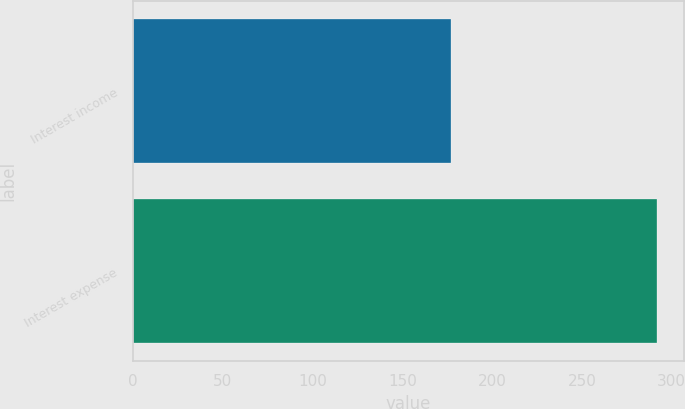Convert chart to OTSL. <chart><loc_0><loc_0><loc_500><loc_500><bar_chart><fcel>Interest income<fcel>Interest expense<nl><fcel>177<fcel>292<nl></chart> 